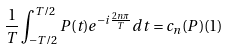<formula> <loc_0><loc_0><loc_500><loc_500>\frac { 1 } { T } \int _ { - T / 2 } ^ { T / 2 } P ( t ) e ^ { - i \frac { 2 n \pi } { T } } d t = c _ { n } ( P ) ( 1 )</formula> 